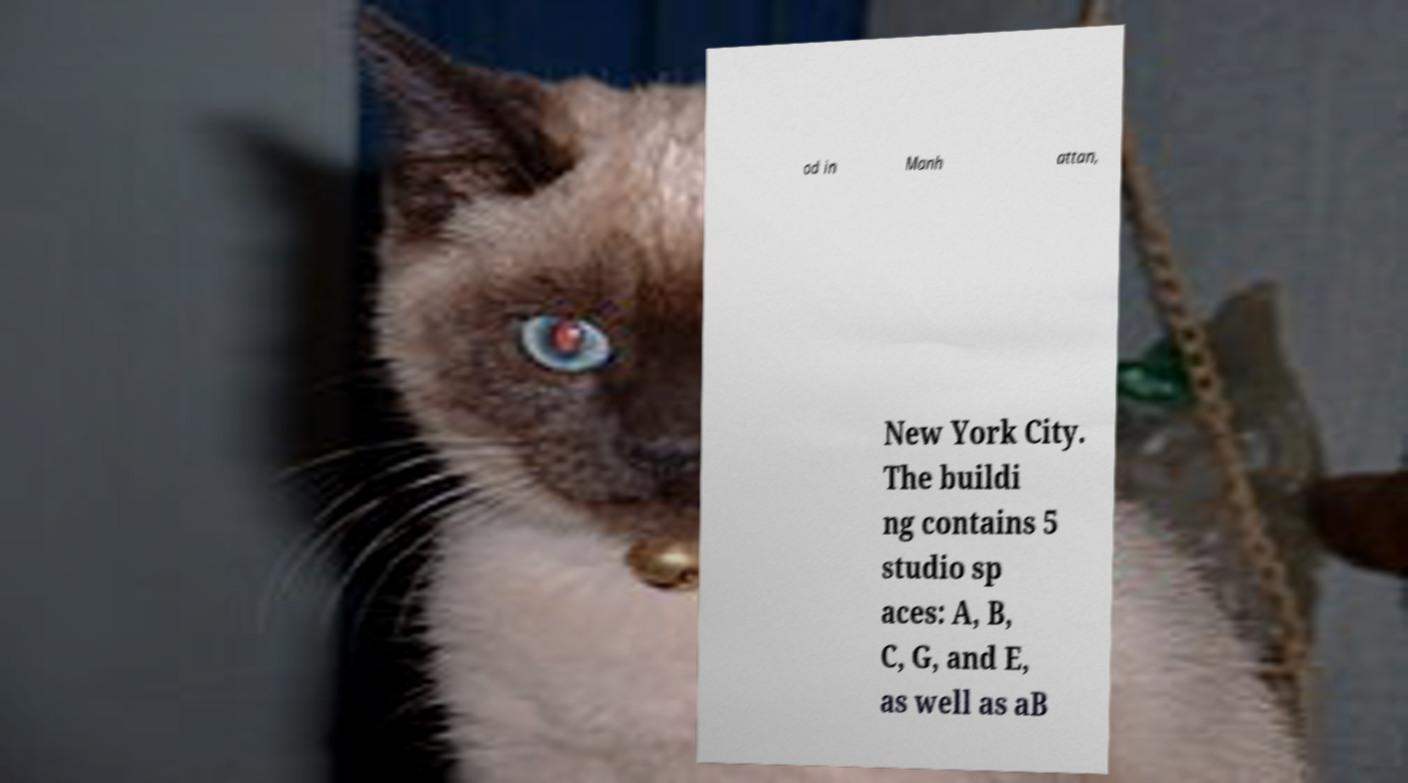Please read and relay the text visible in this image. What does it say? od in Manh attan, New York City. The buildi ng contains 5 studio sp aces: A, B, C, G, and E, as well as aB 